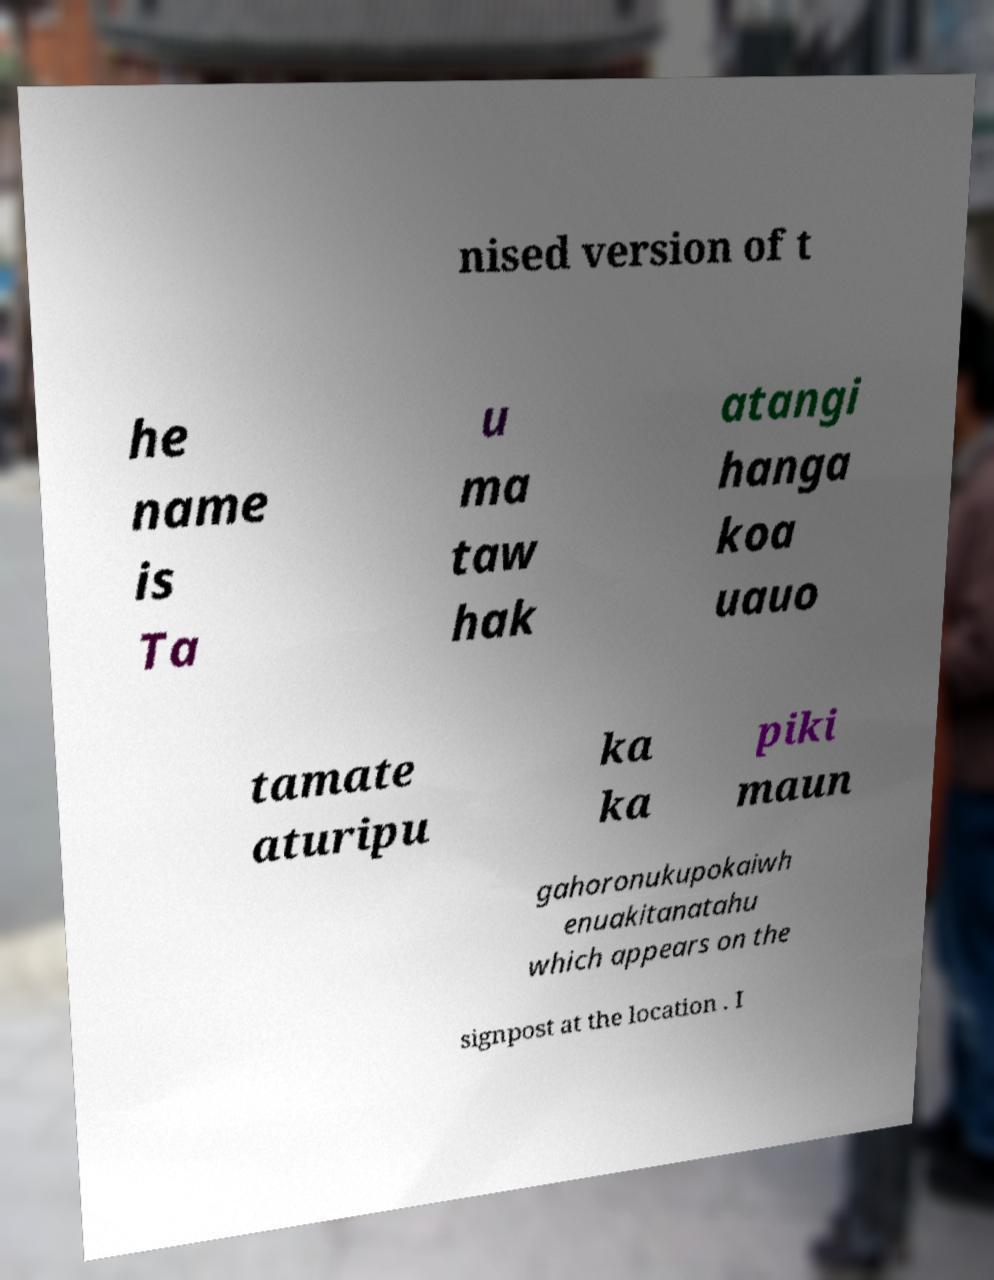Please identify and transcribe the text found in this image. nised version of t he name is Ta u ma taw hak atangi hanga koa uauo tamate aturipu ka ka piki maun gahoronukupokaiwh enuakitanatahu which appears on the signpost at the location . I 